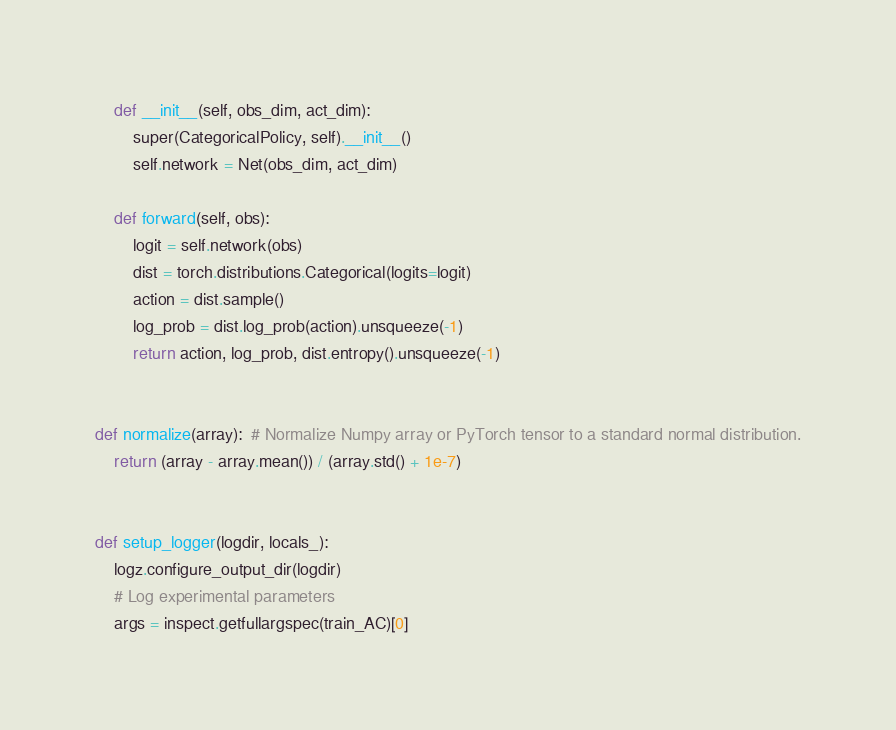Convert code to text. <code><loc_0><loc_0><loc_500><loc_500><_Python_>    def __init__(self, obs_dim, act_dim):
        super(CategoricalPolicy, self).__init__()
        self.network = Net(obs_dim, act_dim)

    def forward(self, obs):
        logit = self.network(obs)
        dist = torch.distributions.Categorical(logits=logit)
        action = dist.sample()
        log_prob = dist.log_prob(action).unsqueeze(-1)
        return action, log_prob, dist.entropy().unsqueeze(-1)


def normalize(array):  # Normalize Numpy array or PyTorch tensor to a standard normal distribution.
    return (array - array.mean()) / (array.std() + 1e-7)


def setup_logger(logdir, locals_):
    logz.configure_output_dir(logdir)
    # Log experimental parameters
    args = inspect.getfullargspec(train_AC)[0]</code> 